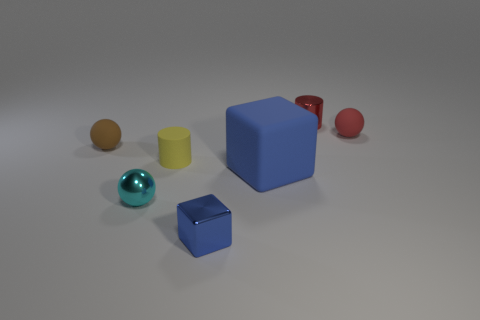Add 1 small balls. How many objects exist? 8 Subtract all balls. How many objects are left? 4 Subtract 0 red blocks. How many objects are left? 7 Subtract all cyan metallic things. Subtract all large blue matte cubes. How many objects are left? 5 Add 7 small balls. How many small balls are left? 10 Add 4 small green matte cylinders. How many small green matte cylinders exist? 4 